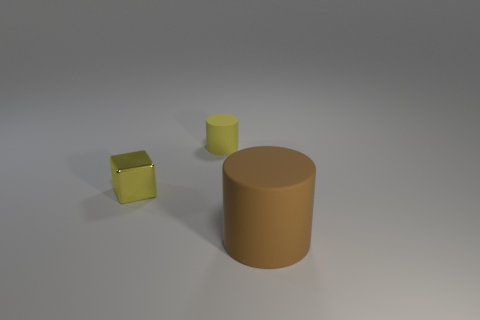Add 2 cylinders. How many objects exist? 5 Subtract all cylinders. How many objects are left? 1 Subtract 1 cubes. How many cubes are left? 0 Add 2 small cylinders. How many small cylinders are left? 3 Add 1 cyan objects. How many cyan objects exist? 1 Subtract 0 cyan cylinders. How many objects are left? 3 Subtract all purple cylinders. Subtract all green balls. How many cylinders are left? 2 Subtract all green cubes. How many cyan cylinders are left? 0 Subtract all big yellow shiny objects. Subtract all blocks. How many objects are left? 2 